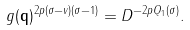Convert formula to latex. <formula><loc_0><loc_0><loc_500><loc_500>g ( \mathbf q ) ^ { 2 p ( \sigma - v ) ( \sigma - 1 ) } = D ^ { - 2 p Q _ { 1 } ( \sigma ) } .</formula> 